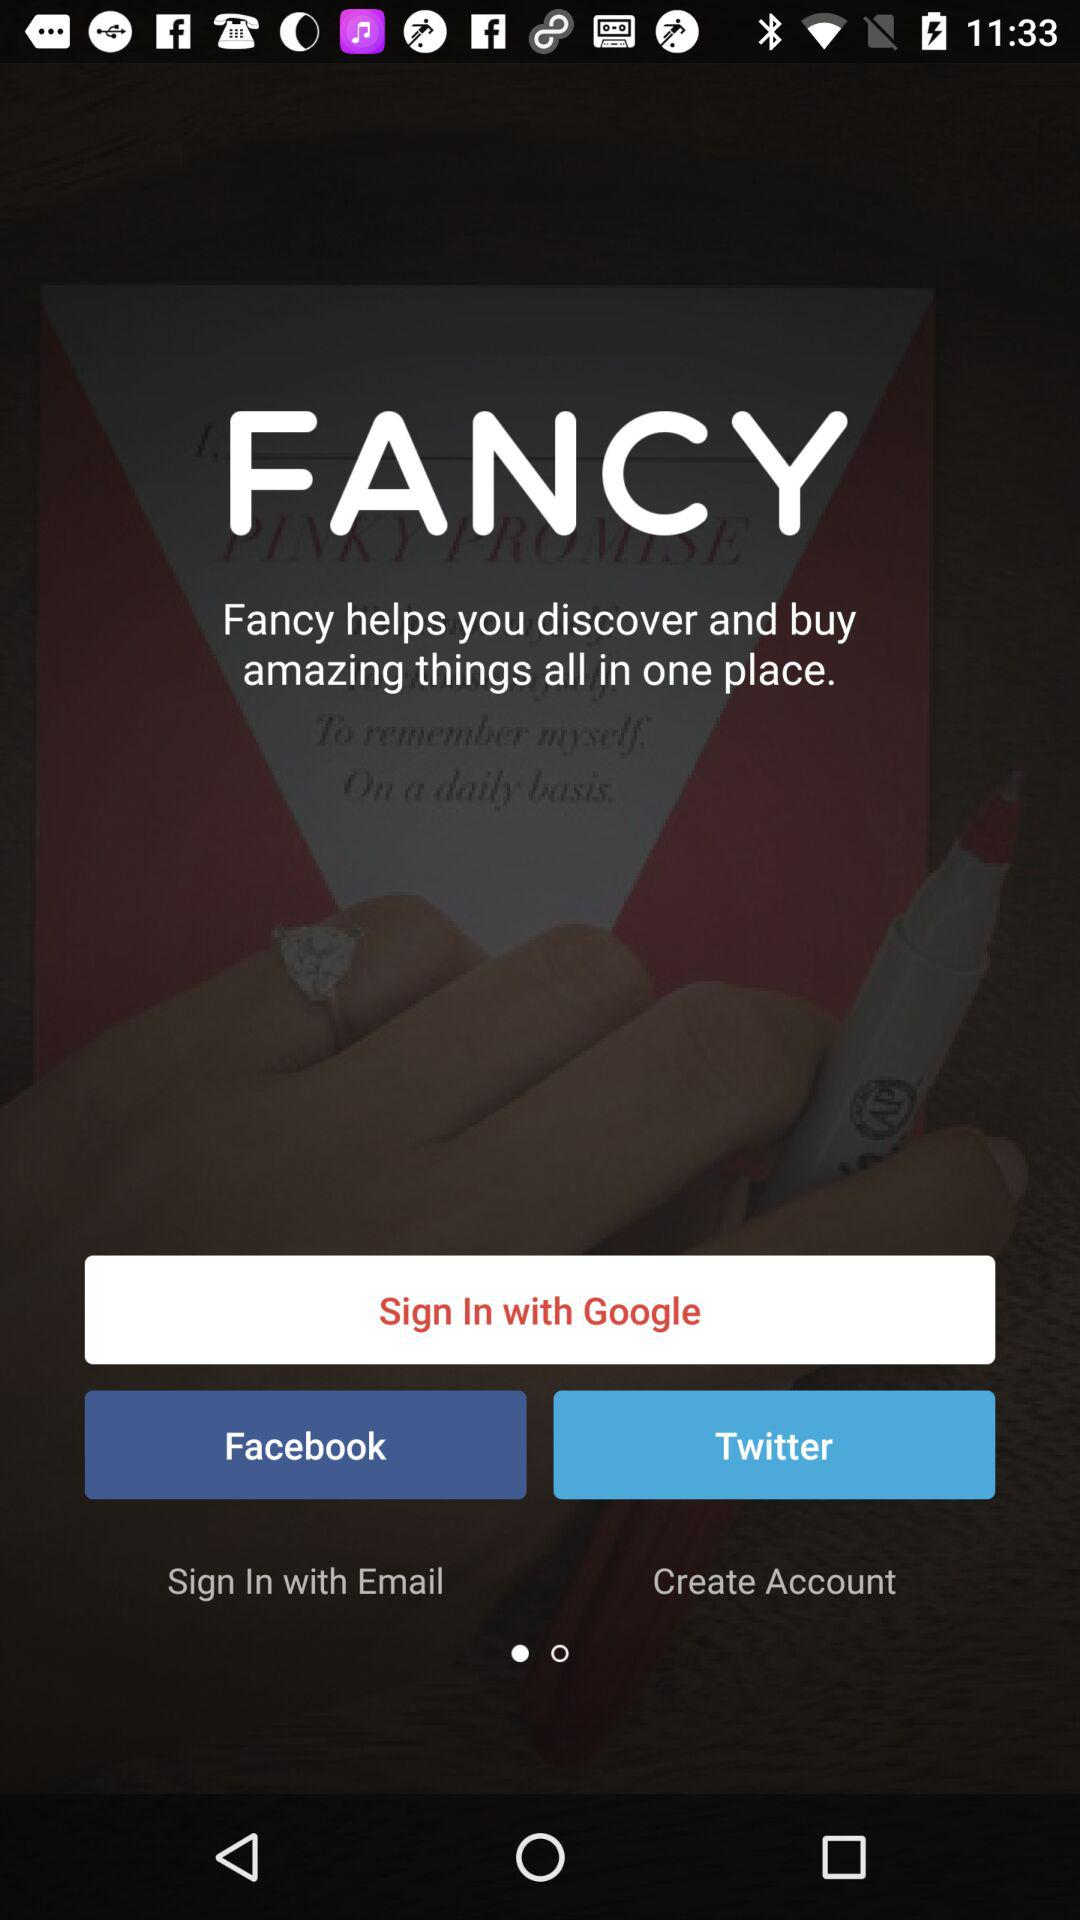Which accounts can I use to sign in? You can use "Google", "Facebook", "Twitter" and "Email" accounts. 